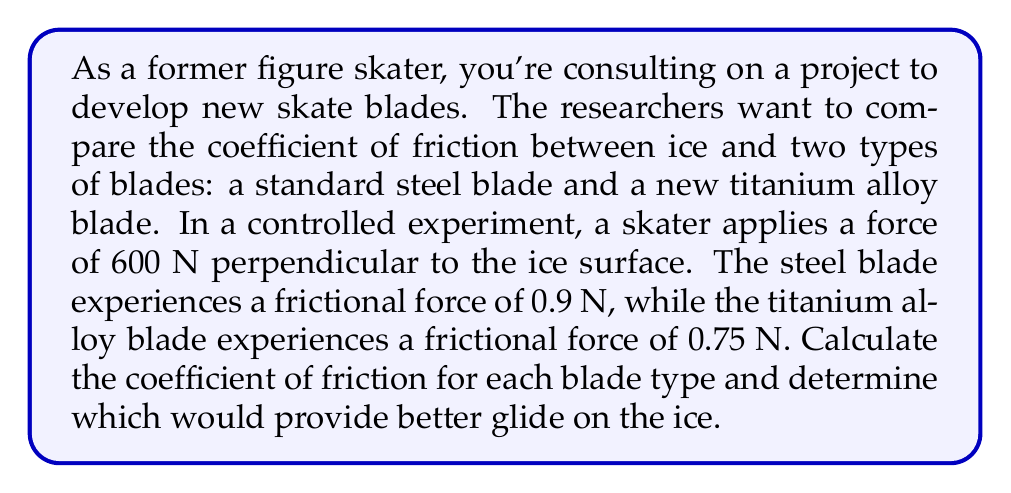Solve this math problem. To solve this problem, we'll use the equation for the coefficient of friction:

$$ \mu = \frac{F_f}{F_n} $$

Where:
$\mu$ = coefficient of friction
$F_f$ = frictional force
$F_n$ = normal force (perpendicular to the surface)

For the steel blade:
$F_f = 0.9$ N
$F_n = 600$ N

$$ \mu_{steel} = \frac{0.9}{600} = 0.0015 $$

For the titanium alloy blade:
$F_f = 0.75$ N
$F_n = 600$ N

$$ \mu_{titanium} = \frac{0.75}{600} = 0.00125 $$

To determine which blade provides better glide, we compare the coefficients of friction. A lower coefficient of friction indicates less resistance and therefore better glide on the ice.

$$ 0.00125 < 0.0015 $$

Thus, the titanium alloy blade has a lower coefficient of friction and would provide better glide on the ice.
Answer: Steel blade: $\mu_{steel} = 0.0015$
Titanium alloy blade: $\mu_{titanium} = 0.00125$
The titanium alloy blade provides better glide on the ice. 